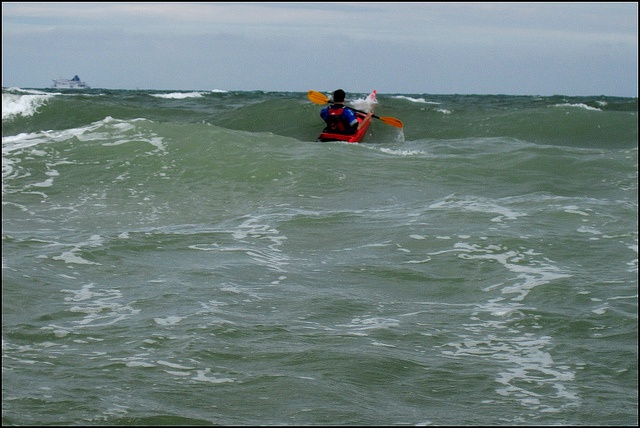Describe the objects in this image and their specific colors. I can see boat in black, darkgray, and maroon tones, people in black, navy, brown, and gray tones, and boat in black, darkgray, gray, and blue tones in this image. 